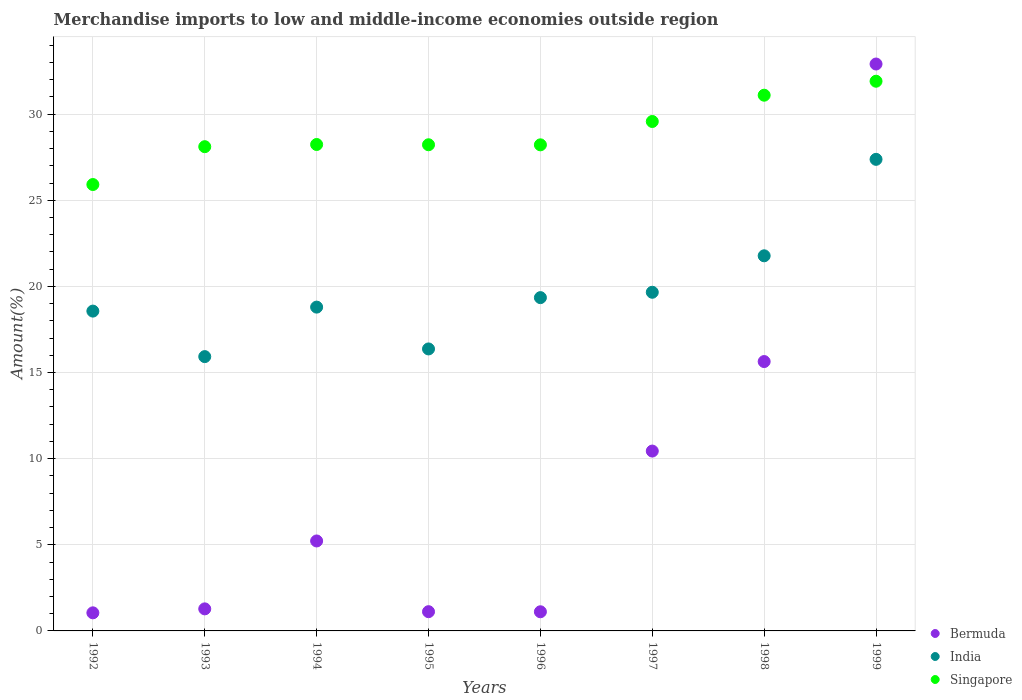How many different coloured dotlines are there?
Ensure brevity in your answer.  3. Is the number of dotlines equal to the number of legend labels?
Provide a succinct answer. Yes. What is the percentage of amount earned from merchandise imports in India in 1998?
Offer a very short reply. 21.77. Across all years, what is the maximum percentage of amount earned from merchandise imports in Singapore?
Make the answer very short. 31.91. Across all years, what is the minimum percentage of amount earned from merchandise imports in Singapore?
Offer a very short reply. 25.91. In which year was the percentage of amount earned from merchandise imports in Singapore maximum?
Provide a succinct answer. 1999. What is the total percentage of amount earned from merchandise imports in India in the graph?
Your response must be concise. 157.81. What is the difference between the percentage of amount earned from merchandise imports in Singapore in 1993 and that in 1998?
Give a very brief answer. -2.99. What is the difference between the percentage of amount earned from merchandise imports in Singapore in 1992 and the percentage of amount earned from merchandise imports in Bermuda in 1997?
Give a very brief answer. 15.47. What is the average percentage of amount earned from merchandise imports in Bermuda per year?
Your response must be concise. 8.6. In the year 1994, what is the difference between the percentage of amount earned from merchandise imports in Bermuda and percentage of amount earned from merchandise imports in India?
Provide a short and direct response. -13.57. In how many years, is the percentage of amount earned from merchandise imports in Singapore greater than 13 %?
Your response must be concise. 8. What is the ratio of the percentage of amount earned from merchandise imports in Bermuda in 1996 to that in 1998?
Keep it short and to the point. 0.07. What is the difference between the highest and the second highest percentage of amount earned from merchandise imports in Singapore?
Provide a succinct answer. 0.81. What is the difference between the highest and the lowest percentage of amount earned from merchandise imports in Singapore?
Provide a short and direct response. 6. Is the percentage of amount earned from merchandise imports in Bermuda strictly less than the percentage of amount earned from merchandise imports in India over the years?
Your answer should be very brief. No. What is the difference between two consecutive major ticks on the Y-axis?
Ensure brevity in your answer.  5. Does the graph contain any zero values?
Give a very brief answer. No. Where does the legend appear in the graph?
Offer a terse response. Bottom right. What is the title of the graph?
Provide a succinct answer. Merchandise imports to low and middle-income economies outside region. What is the label or title of the Y-axis?
Keep it short and to the point. Amount(%). What is the Amount(%) of Bermuda in 1992?
Give a very brief answer. 1.05. What is the Amount(%) in India in 1992?
Offer a terse response. 18.56. What is the Amount(%) of Singapore in 1992?
Your answer should be compact. 25.91. What is the Amount(%) of Bermuda in 1993?
Ensure brevity in your answer.  1.28. What is the Amount(%) of India in 1993?
Offer a very short reply. 15.92. What is the Amount(%) in Singapore in 1993?
Your answer should be very brief. 28.11. What is the Amount(%) of Bermuda in 1994?
Your answer should be compact. 5.22. What is the Amount(%) of India in 1994?
Ensure brevity in your answer.  18.8. What is the Amount(%) in Singapore in 1994?
Offer a terse response. 28.24. What is the Amount(%) of Bermuda in 1995?
Your response must be concise. 1.12. What is the Amount(%) of India in 1995?
Give a very brief answer. 16.37. What is the Amount(%) of Singapore in 1995?
Your answer should be very brief. 28.22. What is the Amount(%) of Bermuda in 1996?
Your answer should be very brief. 1.11. What is the Amount(%) in India in 1996?
Make the answer very short. 19.35. What is the Amount(%) of Singapore in 1996?
Offer a very short reply. 28.22. What is the Amount(%) of Bermuda in 1997?
Ensure brevity in your answer.  10.44. What is the Amount(%) of India in 1997?
Offer a terse response. 19.66. What is the Amount(%) of Singapore in 1997?
Keep it short and to the point. 29.57. What is the Amount(%) of Bermuda in 1998?
Your answer should be compact. 15.64. What is the Amount(%) in India in 1998?
Give a very brief answer. 21.77. What is the Amount(%) of Singapore in 1998?
Your response must be concise. 31.1. What is the Amount(%) in Bermuda in 1999?
Your response must be concise. 32.91. What is the Amount(%) of India in 1999?
Your answer should be very brief. 27.37. What is the Amount(%) of Singapore in 1999?
Make the answer very short. 31.91. Across all years, what is the maximum Amount(%) in Bermuda?
Your answer should be compact. 32.91. Across all years, what is the maximum Amount(%) in India?
Make the answer very short. 27.37. Across all years, what is the maximum Amount(%) in Singapore?
Ensure brevity in your answer.  31.91. Across all years, what is the minimum Amount(%) in Bermuda?
Your answer should be very brief. 1.05. Across all years, what is the minimum Amount(%) of India?
Offer a terse response. 15.92. Across all years, what is the minimum Amount(%) of Singapore?
Your answer should be very brief. 25.91. What is the total Amount(%) in Bermuda in the graph?
Ensure brevity in your answer.  68.76. What is the total Amount(%) of India in the graph?
Ensure brevity in your answer.  157.81. What is the total Amount(%) of Singapore in the graph?
Provide a short and direct response. 231.27. What is the difference between the Amount(%) in Bermuda in 1992 and that in 1993?
Give a very brief answer. -0.23. What is the difference between the Amount(%) in India in 1992 and that in 1993?
Your answer should be compact. 2.64. What is the difference between the Amount(%) of Singapore in 1992 and that in 1993?
Your response must be concise. -2.2. What is the difference between the Amount(%) in Bermuda in 1992 and that in 1994?
Your answer should be compact. -4.17. What is the difference between the Amount(%) in India in 1992 and that in 1994?
Make the answer very short. -0.23. What is the difference between the Amount(%) of Singapore in 1992 and that in 1994?
Give a very brief answer. -2.32. What is the difference between the Amount(%) of Bermuda in 1992 and that in 1995?
Offer a very short reply. -0.07. What is the difference between the Amount(%) of India in 1992 and that in 1995?
Provide a short and direct response. 2.2. What is the difference between the Amount(%) in Singapore in 1992 and that in 1995?
Give a very brief answer. -2.31. What is the difference between the Amount(%) in Bermuda in 1992 and that in 1996?
Your response must be concise. -0.06. What is the difference between the Amount(%) of India in 1992 and that in 1996?
Give a very brief answer. -0.78. What is the difference between the Amount(%) in Singapore in 1992 and that in 1996?
Offer a terse response. -2.3. What is the difference between the Amount(%) in Bermuda in 1992 and that in 1997?
Your response must be concise. -9.39. What is the difference between the Amount(%) of India in 1992 and that in 1997?
Make the answer very short. -1.09. What is the difference between the Amount(%) in Singapore in 1992 and that in 1997?
Offer a terse response. -3.66. What is the difference between the Amount(%) in Bermuda in 1992 and that in 1998?
Offer a terse response. -14.59. What is the difference between the Amount(%) in India in 1992 and that in 1998?
Your response must be concise. -3.21. What is the difference between the Amount(%) in Singapore in 1992 and that in 1998?
Your answer should be very brief. -5.19. What is the difference between the Amount(%) in Bermuda in 1992 and that in 1999?
Offer a terse response. -31.86. What is the difference between the Amount(%) in India in 1992 and that in 1999?
Provide a short and direct response. -8.81. What is the difference between the Amount(%) of Singapore in 1992 and that in 1999?
Your answer should be compact. -6. What is the difference between the Amount(%) in Bermuda in 1993 and that in 1994?
Offer a very short reply. -3.94. What is the difference between the Amount(%) in India in 1993 and that in 1994?
Provide a short and direct response. -2.87. What is the difference between the Amount(%) in Singapore in 1993 and that in 1994?
Provide a short and direct response. -0.13. What is the difference between the Amount(%) in Bermuda in 1993 and that in 1995?
Offer a very short reply. 0.16. What is the difference between the Amount(%) of India in 1993 and that in 1995?
Give a very brief answer. -0.45. What is the difference between the Amount(%) of Singapore in 1993 and that in 1995?
Give a very brief answer. -0.11. What is the difference between the Amount(%) of Bermuda in 1993 and that in 1996?
Your answer should be compact. 0.17. What is the difference between the Amount(%) of India in 1993 and that in 1996?
Keep it short and to the point. -3.42. What is the difference between the Amount(%) in Singapore in 1993 and that in 1996?
Offer a very short reply. -0.11. What is the difference between the Amount(%) of Bermuda in 1993 and that in 1997?
Offer a terse response. -9.16. What is the difference between the Amount(%) in India in 1993 and that in 1997?
Provide a short and direct response. -3.74. What is the difference between the Amount(%) of Singapore in 1993 and that in 1997?
Give a very brief answer. -1.46. What is the difference between the Amount(%) of Bermuda in 1993 and that in 1998?
Your response must be concise. -14.36. What is the difference between the Amount(%) in India in 1993 and that in 1998?
Your response must be concise. -5.85. What is the difference between the Amount(%) in Singapore in 1993 and that in 1998?
Provide a succinct answer. -2.99. What is the difference between the Amount(%) of Bermuda in 1993 and that in 1999?
Provide a succinct answer. -31.63. What is the difference between the Amount(%) of India in 1993 and that in 1999?
Your answer should be very brief. -11.45. What is the difference between the Amount(%) of Singapore in 1993 and that in 1999?
Offer a terse response. -3.8. What is the difference between the Amount(%) in Bermuda in 1994 and that in 1995?
Ensure brevity in your answer.  4.11. What is the difference between the Amount(%) of India in 1994 and that in 1995?
Your answer should be compact. 2.43. What is the difference between the Amount(%) of Singapore in 1994 and that in 1995?
Your answer should be very brief. 0.02. What is the difference between the Amount(%) of Bermuda in 1994 and that in 1996?
Provide a short and direct response. 4.11. What is the difference between the Amount(%) of India in 1994 and that in 1996?
Give a very brief answer. -0.55. What is the difference between the Amount(%) in Singapore in 1994 and that in 1996?
Offer a very short reply. 0.02. What is the difference between the Amount(%) of Bermuda in 1994 and that in 1997?
Your answer should be very brief. -5.22. What is the difference between the Amount(%) in India in 1994 and that in 1997?
Provide a succinct answer. -0.86. What is the difference between the Amount(%) of Singapore in 1994 and that in 1997?
Provide a succinct answer. -1.34. What is the difference between the Amount(%) of Bermuda in 1994 and that in 1998?
Offer a terse response. -10.41. What is the difference between the Amount(%) of India in 1994 and that in 1998?
Offer a very short reply. -2.98. What is the difference between the Amount(%) of Singapore in 1994 and that in 1998?
Offer a very short reply. -2.86. What is the difference between the Amount(%) in Bermuda in 1994 and that in 1999?
Your response must be concise. -27.69. What is the difference between the Amount(%) in India in 1994 and that in 1999?
Offer a very short reply. -8.58. What is the difference between the Amount(%) in Singapore in 1994 and that in 1999?
Provide a short and direct response. -3.67. What is the difference between the Amount(%) of Bermuda in 1995 and that in 1996?
Your answer should be compact. 0.01. What is the difference between the Amount(%) in India in 1995 and that in 1996?
Your answer should be compact. -2.98. What is the difference between the Amount(%) in Singapore in 1995 and that in 1996?
Make the answer very short. 0. What is the difference between the Amount(%) in Bermuda in 1995 and that in 1997?
Provide a short and direct response. -9.32. What is the difference between the Amount(%) in India in 1995 and that in 1997?
Your response must be concise. -3.29. What is the difference between the Amount(%) in Singapore in 1995 and that in 1997?
Offer a terse response. -1.35. What is the difference between the Amount(%) in Bermuda in 1995 and that in 1998?
Provide a succinct answer. -14.52. What is the difference between the Amount(%) in India in 1995 and that in 1998?
Your response must be concise. -5.41. What is the difference between the Amount(%) of Singapore in 1995 and that in 1998?
Your answer should be very brief. -2.88. What is the difference between the Amount(%) in Bermuda in 1995 and that in 1999?
Your answer should be compact. -31.79. What is the difference between the Amount(%) of India in 1995 and that in 1999?
Your answer should be very brief. -11.01. What is the difference between the Amount(%) in Singapore in 1995 and that in 1999?
Your response must be concise. -3.69. What is the difference between the Amount(%) of Bermuda in 1996 and that in 1997?
Your answer should be compact. -9.33. What is the difference between the Amount(%) in India in 1996 and that in 1997?
Make the answer very short. -0.31. What is the difference between the Amount(%) in Singapore in 1996 and that in 1997?
Provide a succinct answer. -1.36. What is the difference between the Amount(%) of Bermuda in 1996 and that in 1998?
Provide a succinct answer. -14.52. What is the difference between the Amount(%) of India in 1996 and that in 1998?
Your response must be concise. -2.43. What is the difference between the Amount(%) in Singapore in 1996 and that in 1998?
Offer a very short reply. -2.88. What is the difference between the Amount(%) of Bermuda in 1996 and that in 1999?
Offer a very short reply. -31.8. What is the difference between the Amount(%) of India in 1996 and that in 1999?
Provide a short and direct response. -8.03. What is the difference between the Amount(%) in Singapore in 1996 and that in 1999?
Your response must be concise. -3.69. What is the difference between the Amount(%) of Bermuda in 1997 and that in 1998?
Keep it short and to the point. -5.2. What is the difference between the Amount(%) of India in 1997 and that in 1998?
Offer a very short reply. -2.12. What is the difference between the Amount(%) in Singapore in 1997 and that in 1998?
Make the answer very short. -1.53. What is the difference between the Amount(%) of Bermuda in 1997 and that in 1999?
Ensure brevity in your answer.  -22.47. What is the difference between the Amount(%) of India in 1997 and that in 1999?
Offer a terse response. -7.72. What is the difference between the Amount(%) in Singapore in 1997 and that in 1999?
Make the answer very short. -2.34. What is the difference between the Amount(%) in Bermuda in 1998 and that in 1999?
Your answer should be very brief. -17.27. What is the difference between the Amount(%) in India in 1998 and that in 1999?
Provide a succinct answer. -5.6. What is the difference between the Amount(%) of Singapore in 1998 and that in 1999?
Make the answer very short. -0.81. What is the difference between the Amount(%) in Bermuda in 1992 and the Amount(%) in India in 1993?
Make the answer very short. -14.87. What is the difference between the Amount(%) of Bermuda in 1992 and the Amount(%) of Singapore in 1993?
Provide a short and direct response. -27.06. What is the difference between the Amount(%) of India in 1992 and the Amount(%) of Singapore in 1993?
Offer a very short reply. -9.54. What is the difference between the Amount(%) of Bermuda in 1992 and the Amount(%) of India in 1994?
Your answer should be compact. -17.75. What is the difference between the Amount(%) of Bermuda in 1992 and the Amount(%) of Singapore in 1994?
Give a very brief answer. -27.19. What is the difference between the Amount(%) of India in 1992 and the Amount(%) of Singapore in 1994?
Your answer should be compact. -9.67. What is the difference between the Amount(%) of Bermuda in 1992 and the Amount(%) of India in 1995?
Ensure brevity in your answer.  -15.32. What is the difference between the Amount(%) in Bermuda in 1992 and the Amount(%) in Singapore in 1995?
Offer a terse response. -27.17. What is the difference between the Amount(%) in India in 1992 and the Amount(%) in Singapore in 1995?
Ensure brevity in your answer.  -9.66. What is the difference between the Amount(%) of Bermuda in 1992 and the Amount(%) of India in 1996?
Offer a very short reply. -18.3. What is the difference between the Amount(%) of Bermuda in 1992 and the Amount(%) of Singapore in 1996?
Offer a terse response. -27.17. What is the difference between the Amount(%) in India in 1992 and the Amount(%) in Singapore in 1996?
Your response must be concise. -9.65. What is the difference between the Amount(%) in Bermuda in 1992 and the Amount(%) in India in 1997?
Offer a terse response. -18.61. What is the difference between the Amount(%) of Bermuda in 1992 and the Amount(%) of Singapore in 1997?
Make the answer very short. -28.52. What is the difference between the Amount(%) in India in 1992 and the Amount(%) in Singapore in 1997?
Provide a short and direct response. -11.01. What is the difference between the Amount(%) in Bermuda in 1992 and the Amount(%) in India in 1998?
Offer a terse response. -20.73. What is the difference between the Amount(%) of Bermuda in 1992 and the Amount(%) of Singapore in 1998?
Offer a terse response. -30.05. What is the difference between the Amount(%) of India in 1992 and the Amount(%) of Singapore in 1998?
Make the answer very short. -12.53. What is the difference between the Amount(%) of Bermuda in 1992 and the Amount(%) of India in 1999?
Offer a very short reply. -26.32. What is the difference between the Amount(%) in Bermuda in 1992 and the Amount(%) in Singapore in 1999?
Make the answer very short. -30.86. What is the difference between the Amount(%) in India in 1992 and the Amount(%) in Singapore in 1999?
Your response must be concise. -13.34. What is the difference between the Amount(%) in Bermuda in 1993 and the Amount(%) in India in 1994?
Make the answer very short. -17.52. What is the difference between the Amount(%) in Bermuda in 1993 and the Amount(%) in Singapore in 1994?
Provide a short and direct response. -26.96. What is the difference between the Amount(%) in India in 1993 and the Amount(%) in Singapore in 1994?
Provide a succinct answer. -12.31. What is the difference between the Amount(%) of Bermuda in 1993 and the Amount(%) of India in 1995?
Your answer should be very brief. -15.09. What is the difference between the Amount(%) in Bermuda in 1993 and the Amount(%) in Singapore in 1995?
Offer a terse response. -26.94. What is the difference between the Amount(%) of India in 1993 and the Amount(%) of Singapore in 1995?
Ensure brevity in your answer.  -12.3. What is the difference between the Amount(%) in Bermuda in 1993 and the Amount(%) in India in 1996?
Keep it short and to the point. -18.07. What is the difference between the Amount(%) in Bermuda in 1993 and the Amount(%) in Singapore in 1996?
Your answer should be very brief. -26.94. What is the difference between the Amount(%) of India in 1993 and the Amount(%) of Singapore in 1996?
Your response must be concise. -12.29. What is the difference between the Amount(%) in Bermuda in 1993 and the Amount(%) in India in 1997?
Ensure brevity in your answer.  -18.38. What is the difference between the Amount(%) in Bermuda in 1993 and the Amount(%) in Singapore in 1997?
Your answer should be very brief. -28.29. What is the difference between the Amount(%) in India in 1993 and the Amount(%) in Singapore in 1997?
Give a very brief answer. -13.65. What is the difference between the Amount(%) of Bermuda in 1993 and the Amount(%) of India in 1998?
Offer a terse response. -20.49. What is the difference between the Amount(%) of Bermuda in 1993 and the Amount(%) of Singapore in 1998?
Make the answer very short. -29.82. What is the difference between the Amount(%) of India in 1993 and the Amount(%) of Singapore in 1998?
Ensure brevity in your answer.  -15.17. What is the difference between the Amount(%) of Bermuda in 1993 and the Amount(%) of India in 1999?
Make the answer very short. -26.09. What is the difference between the Amount(%) in Bermuda in 1993 and the Amount(%) in Singapore in 1999?
Your answer should be very brief. -30.63. What is the difference between the Amount(%) of India in 1993 and the Amount(%) of Singapore in 1999?
Your response must be concise. -15.99. What is the difference between the Amount(%) of Bermuda in 1994 and the Amount(%) of India in 1995?
Make the answer very short. -11.15. What is the difference between the Amount(%) in Bermuda in 1994 and the Amount(%) in Singapore in 1995?
Ensure brevity in your answer.  -23. What is the difference between the Amount(%) of India in 1994 and the Amount(%) of Singapore in 1995?
Offer a very short reply. -9.42. What is the difference between the Amount(%) of Bermuda in 1994 and the Amount(%) of India in 1996?
Provide a short and direct response. -14.12. What is the difference between the Amount(%) in Bermuda in 1994 and the Amount(%) in Singapore in 1996?
Your response must be concise. -22.99. What is the difference between the Amount(%) in India in 1994 and the Amount(%) in Singapore in 1996?
Offer a very short reply. -9.42. What is the difference between the Amount(%) in Bermuda in 1994 and the Amount(%) in India in 1997?
Give a very brief answer. -14.44. What is the difference between the Amount(%) of Bermuda in 1994 and the Amount(%) of Singapore in 1997?
Make the answer very short. -24.35. What is the difference between the Amount(%) of India in 1994 and the Amount(%) of Singapore in 1997?
Your answer should be very brief. -10.78. What is the difference between the Amount(%) of Bermuda in 1994 and the Amount(%) of India in 1998?
Your response must be concise. -16.55. What is the difference between the Amount(%) of Bermuda in 1994 and the Amount(%) of Singapore in 1998?
Offer a very short reply. -25.88. What is the difference between the Amount(%) of India in 1994 and the Amount(%) of Singapore in 1998?
Make the answer very short. -12.3. What is the difference between the Amount(%) in Bermuda in 1994 and the Amount(%) in India in 1999?
Your response must be concise. -22.15. What is the difference between the Amount(%) in Bermuda in 1994 and the Amount(%) in Singapore in 1999?
Your response must be concise. -26.69. What is the difference between the Amount(%) in India in 1994 and the Amount(%) in Singapore in 1999?
Your response must be concise. -13.11. What is the difference between the Amount(%) of Bermuda in 1995 and the Amount(%) of India in 1996?
Your response must be concise. -18.23. What is the difference between the Amount(%) of Bermuda in 1995 and the Amount(%) of Singapore in 1996?
Offer a terse response. -27.1. What is the difference between the Amount(%) of India in 1995 and the Amount(%) of Singapore in 1996?
Ensure brevity in your answer.  -11.85. What is the difference between the Amount(%) in Bermuda in 1995 and the Amount(%) in India in 1997?
Make the answer very short. -18.54. What is the difference between the Amount(%) of Bermuda in 1995 and the Amount(%) of Singapore in 1997?
Ensure brevity in your answer.  -28.45. What is the difference between the Amount(%) of India in 1995 and the Amount(%) of Singapore in 1997?
Give a very brief answer. -13.2. What is the difference between the Amount(%) in Bermuda in 1995 and the Amount(%) in India in 1998?
Make the answer very short. -20.66. What is the difference between the Amount(%) of Bermuda in 1995 and the Amount(%) of Singapore in 1998?
Give a very brief answer. -29.98. What is the difference between the Amount(%) in India in 1995 and the Amount(%) in Singapore in 1998?
Ensure brevity in your answer.  -14.73. What is the difference between the Amount(%) of Bermuda in 1995 and the Amount(%) of India in 1999?
Provide a succinct answer. -26.26. What is the difference between the Amount(%) of Bermuda in 1995 and the Amount(%) of Singapore in 1999?
Make the answer very short. -30.79. What is the difference between the Amount(%) of India in 1995 and the Amount(%) of Singapore in 1999?
Provide a succinct answer. -15.54. What is the difference between the Amount(%) of Bermuda in 1996 and the Amount(%) of India in 1997?
Give a very brief answer. -18.55. What is the difference between the Amount(%) of Bermuda in 1996 and the Amount(%) of Singapore in 1997?
Keep it short and to the point. -28.46. What is the difference between the Amount(%) of India in 1996 and the Amount(%) of Singapore in 1997?
Offer a terse response. -10.22. What is the difference between the Amount(%) in Bermuda in 1996 and the Amount(%) in India in 1998?
Your response must be concise. -20.66. What is the difference between the Amount(%) of Bermuda in 1996 and the Amount(%) of Singapore in 1998?
Provide a short and direct response. -29.99. What is the difference between the Amount(%) of India in 1996 and the Amount(%) of Singapore in 1998?
Your answer should be compact. -11.75. What is the difference between the Amount(%) in Bermuda in 1996 and the Amount(%) in India in 1999?
Offer a very short reply. -26.26. What is the difference between the Amount(%) of Bermuda in 1996 and the Amount(%) of Singapore in 1999?
Keep it short and to the point. -30.8. What is the difference between the Amount(%) in India in 1996 and the Amount(%) in Singapore in 1999?
Provide a succinct answer. -12.56. What is the difference between the Amount(%) of Bermuda in 1997 and the Amount(%) of India in 1998?
Your answer should be compact. -11.33. What is the difference between the Amount(%) in Bermuda in 1997 and the Amount(%) in Singapore in 1998?
Your answer should be compact. -20.66. What is the difference between the Amount(%) of India in 1997 and the Amount(%) of Singapore in 1998?
Provide a short and direct response. -11.44. What is the difference between the Amount(%) in Bermuda in 1997 and the Amount(%) in India in 1999?
Provide a short and direct response. -16.93. What is the difference between the Amount(%) in Bermuda in 1997 and the Amount(%) in Singapore in 1999?
Provide a succinct answer. -21.47. What is the difference between the Amount(%) of India in 1997 and the Amount(%) of Singapore in 1999?
Offer a terse response. -12.25. What is the difference between the Amount(%) in Bermuda in 1998 and the Amount(%) in India in 1999?
Ensure brevity in your answer.  -11.74. What is the difference between the Amount(%) of Bermuda in 1998 and the Amount(%) of Singapore in 1999?
Your answer should be very brief. -16.27. What is the difference between the Amount(%) in India in 1998 and the Amount(%) in Singapore in 1999?
Make the answer very short. -10.13. What is the average Amount(%) in Bermuda per year?
Ensure brevity in your answer.  8.6. What is the average Amount(%) of India per year?
Offer a very short reply. 19.73. What is the average Amount(%) of Singapore per year?
Your answer should be very brief. 28.91. In the year 1992, what is the difference between the Amount(%) in Bermuda and Amount(%) in India?
Your answer should be compact. -17.51. In the year 1992, what is the difference between the Amount(%) of Bermuda and Amount(%) of Singapore?
Your answer should be compact. -24.86. In the year 1992, what is the difference between the Amount(%) in India and Amount(%) in Singapore?
Offer a very short reply. -7.35. In the year 1993, what is the difference between the Amount(%) in Bermuda and Amount(%) in India?
Provide a short and direct response. -14.64. In the year 1993, what is the difference between the Amount(%) of Bermuda and Amount(%) of Singapore?
Your answer should be very brief. -26.83. In the year 1993, what is the difference between the Amount(%) of India and Amount(%) of Singapore?
Provide a short and direct response. -12.19. In the year 1994, what is the difference between the Amount(%) of Bermuda and Amount(%) of India?
Keep it short and to the point. -13.57. In the year 1994, what is the difference between the Amount(%) in Bermuda and Amount(%) in Singapore?
Your answer should be compact. -23.01. In the year 1994, what is the difference between the Amount(%) of India and Amount(%) of Singapore?
Your answer should be compact. -9.44. In the year 1995, what is the difference between the Amount(%) in Bermuda and Amount(%) in India?
Your answer should be compact. -15.25. In the year 1995, what is the difference between the Amount(%) in Bermuda and Amount(%) in Singapore?
Give a very brief answer. -27.1. In the year 1995, what is the difference between the Amount(%) of India and Amount(%) of Singapore?
Give a very brief answer. -11.85. In the year 1996, what is the difference between the Amount(%) in Bermuda and Amount(%) in India?
Offer a very short reply. -18.24. In the year 1996, what is the difference between the Amount(%) of Bermuda and Amount(%) of Singapore?
Your answer should be very brief. -27.1. In the year 1996, what is the difference between the Amount(%) of India and Amount(%) of Singapore?
Make the answer very short. -8.87. In the year 1997, what is the difference between the Amount(%) in Bermuda and Amount(%) in India?
Offer a very short reply. -9.22. In the year 1997, what is the difference between the Amount(%) in Bermuda and Amount(%) in Singapore?
Give a very brief answer. -19.13. In the year 1997, what is the difference between the Amount(%) of India and Amount(%) of Singapore?
Offer a very short reply. -9.91. In the year 1998, what is the difference between the Amount(%) of Bermuda and Amount(%) of India?
Offer a terse response. -6.14. In the year 1998, what is the difference between the Amount(%) of Bermuda and Amount(%) of Singapore?
Provide a short and direct response. -15.46. In the year 1998, what is the difference between the Amount(%) of India and Amount(%) of Singapore?
Provide a succinct answer. -9.32. In the year 1999, what is the difference between the Amount(%) in Bermuda and Amount(%) in India?
Make the answer very short. 5.53. In the year 1999, what is the difference between the Amount(%) in Bermuda and Amount(%) in Singapore?
Your answer should be very brief. 1. In the year 1999, what is the difference between the Amount(%) in India and Amount(%) in Singapore?
Give a very brief answer. -4.53. What is the ratio of the Amount(%) in Bermuda in 1992 to that in 1993?
Your answer should be compact. 0.82. What is the ratio of the Amount(%) in India in 1992 to that in 1993?
Your response must be concise. 1.17. What is the ratio of the Amount(%) in Singapore in 1992 to that in 1993?
Your answer should be very brief. 0.92. What is the ratio of the Amount(%) in Bermuda in 1992 to that in 1994?
Make the answer very short. 0.2. What is the ratio of the Amount(%) in India in 1992 to that in 1994?
Provide a succinct answer. 0.99. What is the ratio of the Amount(%) of Singapore in 1992 to that in 1994?
Keep it short and to the point. 0.92. What is the ratio of the Amount(%) in Bermuda in 1992 to that in 1995?
Give a very brief answer. 0.94. What is the ratio of the Amount(%) of India in 1992 to that in 1995?
Keep it short and to the point. 1.13. What is the ratio of the Amount(%) of Singapore in 1992 to that in 1995?
Provide a short and direct response. 0.92. What is the ratio of the Amount(%) in Bermuda in 1992 to that in 1996?
Make the answer very short. 0.94. What is the ratio of the Amount(%) in India in 1992 to that in 1996?
Keep it short and to the point. 0.96. What is the ratio of the Amount(%) in Singapore in 1992 to that in 1996?
Your response must be concise. 0.92. What is the ratio of the Amount(%) in Bermuda in 1992 to that in 1997?
Keep it short and to the point. 0.1. What is the ratio of the Amount(%) in India in 1992 to that in 1997?
Offer a terse response. 0.94. What is the ratio of the Amount(%) in Singapore in 1992 to that in 1997?
Offer a terse response. 0.88. What is the ratio of the Amount(%) in Bermuda in 1992 to that in 1998?
Your answer should be compact. 0.07. What is the ratio of the Amount(%) in India in 1992 to that in 1998?
Keep it short and to the point. 0.85. What is the ratio of the Amount(%) of Singapore in 1992 to that in 1998?
Your answer should be very brief. 0.83. What is the ratio of the Amount(%) in Bermuda in 1992 to that in 1999?
Give a very brief answer. 0.03. What is the ratio of the Amount(%) in India in 1992 to that in 1999?
Ensure brevity in your answer.  0.68. What is the ratio of the Amount(%) in Singapore in 1992 to that in 1999?
Offer a terse response. 0.81. What is the ratio of the Amount(%) of Bermuda in 1993 to that in 1994?
Ensure brevity in your answer.  0.25. What is the ratio of the Amount(%) of India in 1993 to that in 1994?
Keep it short and to the point. 0.85. What is the ratio of the Amount(%) in Singapore in 1993 to that in 1994?
Provide a short and direct response. 1. What is the ratio of the Amount(%) of Bermuda in 1993 to that in 1995?
Ensure brevity in your answer.  1.15. What is the ratio of the Amount(%) of India in 1993 to that in 1995?
Your response must be concise. 0.97. What is the ratio of the Amount(%) of Bermuda in 1993 to that in 1996?
Ensure brevity in your answer.  1.15. What is the ratio of the Amount(%) of India in 1993 to that in 1996?
Provide a succinct answer. 0.82. What is the ratio of the Amount(%) of Bermuda in 1993 to that in 1997?
Your response must be concise. 0.12. What is the ratio of the Amount(%) in India in 1993 to that in 1997?
Provide a short and direct response. 0.81. What is the ratio of the Amount(%) in Singapore in 1993 to that in 1997?
Provide a short and direct response. 0.95. What is the ratio of the Amount(%) of Bermuda in 1993 to that in 1998?
Provide a succinct answer. 0.08. What is the ratio of the Amount(%) of India in 1993 to that in 1998?
Offer a very short reply. 0.73. What is the ratio of the Amount(%) of Singapore in 1993 to that in 1998?
Your answer should be compact. 0.9. What is the ratio of the Amount(%) of Bermuda in 1993 to that in 1999?
Ensure brevity in your answer.  0.04. What is the ratio of the Amount(%) in India in 1993 to that in 1999?
Provide a short and direct response. 0.58. What is the ratio of the Amount(%) of Singapore in 1993 to that in 1999?
Provide a succinct answer. 0.88. What is the ratio of the Amount(%) of Bermuda in 1994 to that in 1995?
Ensure brevity in your answer.  4.68. What is the ratio of the Amount(%) in India in 1994 to that in 1995?
Your answer should be compact. 1.15. What is the ratio of the Amount(%) in Singapore in 1994 to that in 1995?
Provide a succinct answer. 1. What is the ratio of the Amount(%) in Bermuda in 1994 to that in 1996?
Your response must be concise. 4.7. What is the ratio of the Amount(%) in India in 1994 to that in 1996?
Offer a terse response. 0.97. What is the ratio of the Amount(%) in Bermuda in 1994 to that in 1997?
Offer a terse response. 0.5. What is the ratio of the Amount(%) of India in 1994 to that in 1997?
Offer a terse response. 0.96. What is the ratio of the Amount(%) in Singapore in 1994 to that in 1997?
Provide a succinct answer. 0.95. What is the ratio of the Amount(%) in Bermuda in 1994 to that in 1998?
Offer a very short reply. 0.33. What is the ratio of the Amount(%) in India in 1994 to that in 1998?
Offer a very short reply. 0.86. What is the ratio of the Amount(%) of Singapore in 1994 to that in 1998?
Provide a short and direct response. 0.91. What is the ratio of the Amount(%) of Bermuda in 1994 to that in 1999?
Ensure brevity in your answer.  0.16. What is the ratio of the Amount(%) of India in 1994 to that in 1999?
Offer a terse response. 0.69. What is the ratio of the Amount(%) in Singapore in 1994 to that in 1999?
Make the answer very short. 0.88. What is the ratio of the Amount(%) of Bermuda in 1995 to that in 1996?
Offer a terse response. 1. What is the ratio of the Amount(%) in India in 1995 to that in 1996?
Make the answer very short. 0.85. What is the ratio of the Amount(%) of Bermuda in 1995 to that in 1997?
Give a very brief answer. 0.11. What is the ratio of the Amount(%) of India in 1995 to that in 1997?
Make the answer very short. 0.83. What is the ratio of the Amount(%) of Singapore in 1995 to that in 1997?
Keep it short and to the point. 0.95. What is the ratio of the Amount(%) in Bermuda in 1995 to that in 1998?
Your answer should be compact. 0.07. What is the ratio of the Amount(%) in India in 1995 to that in 1998?
Provide a short and direct response. 0.75. What is the ratio of the Amount(%) in Singapore in 1995 to that in 1998?
Provide a short and direct response. 0.91. What is the ratio of the Amount(%) in Bermuda in 1995 to that in 1999?
Provide a short and direct response. 0.03. What is the ratio of the Amount(%) in India in 1995 to that in 1999?
Your answer should be compact. 0.6. What is the ratio of the Amount(%) of Singapore in 1995 to that in 1999?
Provide a succinct answer. 0.88. What is the ratio of the Amount(%) in Bermuda in 1996 to that in 1997?
Offer a very short reply. 0.11. What is the ratio of the Amount(%) in India in 1996 to that in 1997?
Your answer should be very brief. 0.98. What is the ratio of the Amount(%) of Singapore in 1996 to that in 1997?
Make the answer very short. 0.95. What is the ratio of the Amount(%) of Bermuda in 1996 to that in 1998?
Keep it short and to the point. 0.07. What is the ratio of the Amount(%) of India in 1996 to that in 1998?
Provide a short and direct response. 0.89. What is the ratio of the Amount(%) in Singapore in 1996 to that in 1998?
Provide a succinct answer. 0.91. What is the ratio of the Amount(%) in Bermuda in 1996 to that in 1999?
Provide a short and direct response. 0.03. What is the ratio of the Amount(%) of India in 1996 to that in 1999?
Offer a terse response. 0.71. What is the ratio of the Amount(%) in Singapore in 1996 to that in 1999?
Give a very brief answer. 0.88. What is the ratio of the Amount(%) in Bermuda in 1997 to that in 1998?
Your answer should be very brief. 0.67. What is the ratio of the Amount(%) of India in 1997 to that in 1998?
Keep it short and to the point. 0.9. What is the ratio of the Amount(%) in Singapore in 1997 to that in 1998?
Offer a very short reply. 0.95. What is the ratio of the Amount(%) in Bermuda in 1997 to that in 1999?
Offer a terse response. 0.32. What is the ratio of the Amount(%) in India in 1997 to that in 1999?
Offer a terse response. 0.72. What is the ratio of the Amount(%) of Singapore in 1997 to that in 1999?
Your answer should be compact. 0.93. What is the ratio of the Amount(%) of Bermuda in 1998 to that in 1999?
Your answer should be very brief. 0.48. What is the ratio of the Amount(%) of India in 1998 to that in 1999?
Ensure brevity in your answer.  0.8. What is the ratio of the Amount(%) of Singapore in 1998 to that in 1999?
Provide a succinct answer. 0.97. What is the difference between the highest and the second highest Amount(%) in Bermuda?
Make the answer very short. 17.27. What is the difference between the highest and the second highest Amount(%) in India?
Your answer should be very brief. 5.6. What is the difference between the highest and the second highest Amount(%) in Singapore?
Offer a very short reply. 0.81. What is the difference between the highest and the lowest Amount(%) of Bermuda?
Provide a succinct answer. 31.86. What is the difference between the highest and the lowest Amount(%) in India?
Your answer should be very brief. 11.45. What is the difference between the highest and the lowest Amount(%) of Singapore?
Ensure brevity in your answer.  6. 